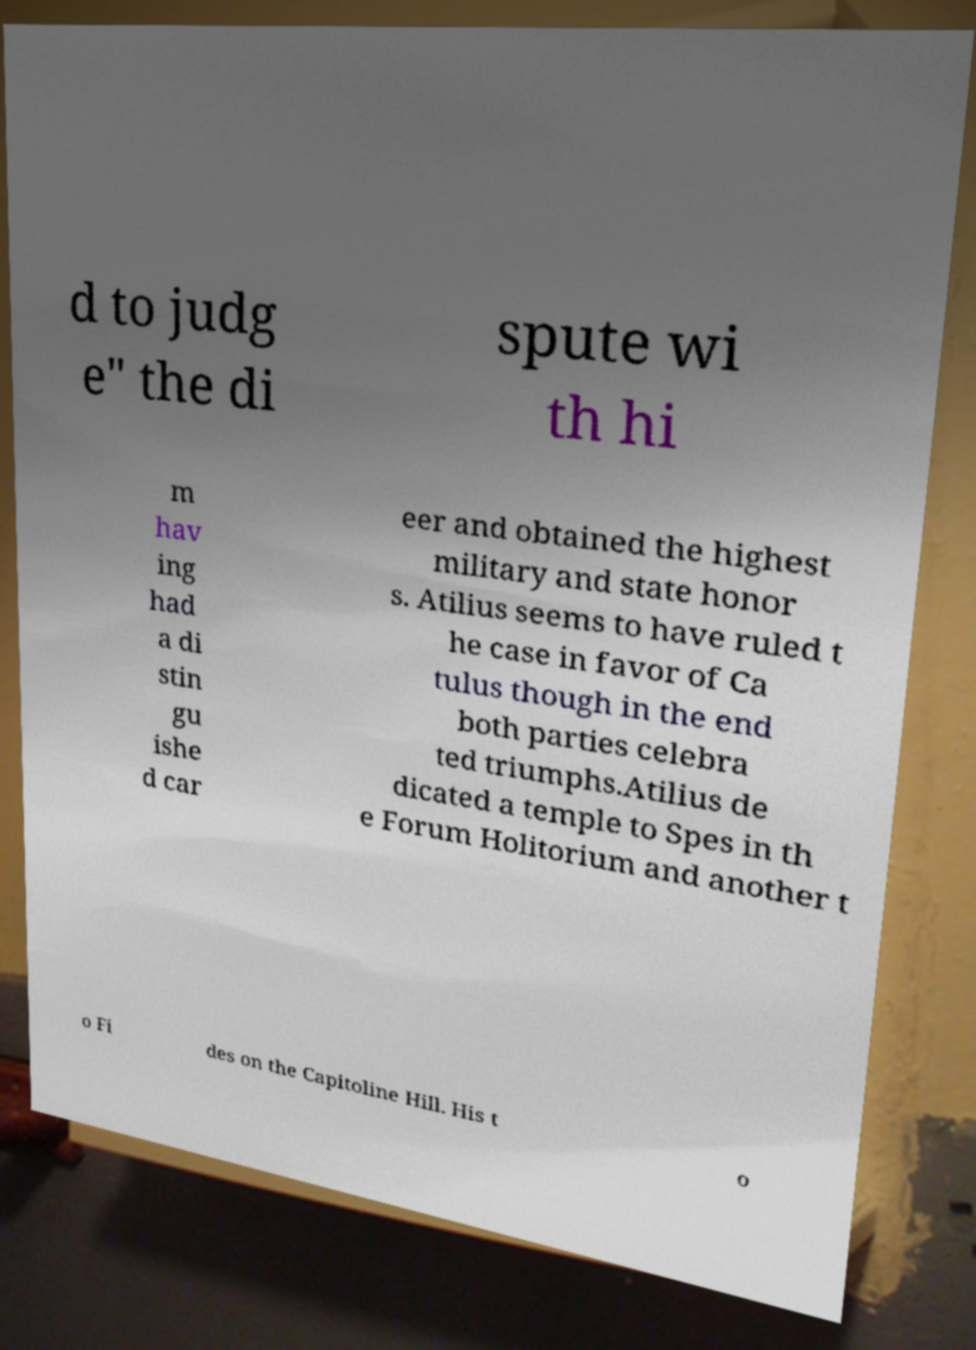What messages or text are displayed in this image? I need them in a readable, typed format. d to judg e" the di spute wi th hi m hav ing had a di stin gu ishe d car eer and obtained the highest military and state honor s. Atilius seems to have ruled t he case in favor of Ca tulus though in the end both parties celebra ted triumphs.Atilius de dicated a temple to Spes in th e Forum Holitorium and another t o Fi des on the Capitoline Hill. His t o 